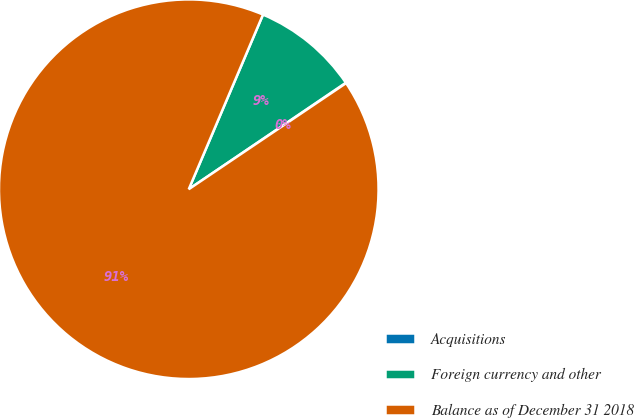Convert chart to OTSL. <chart><loc_0><loc_0><loc_500><loc_500><pie_chart><fcel>Acquisitions<fcel>Foreign currency and other<fcel>Balance as of December 31 2018<nl><fcel>0.04%<fcel>9.12%<fcel>90.85%<nl></chart> 